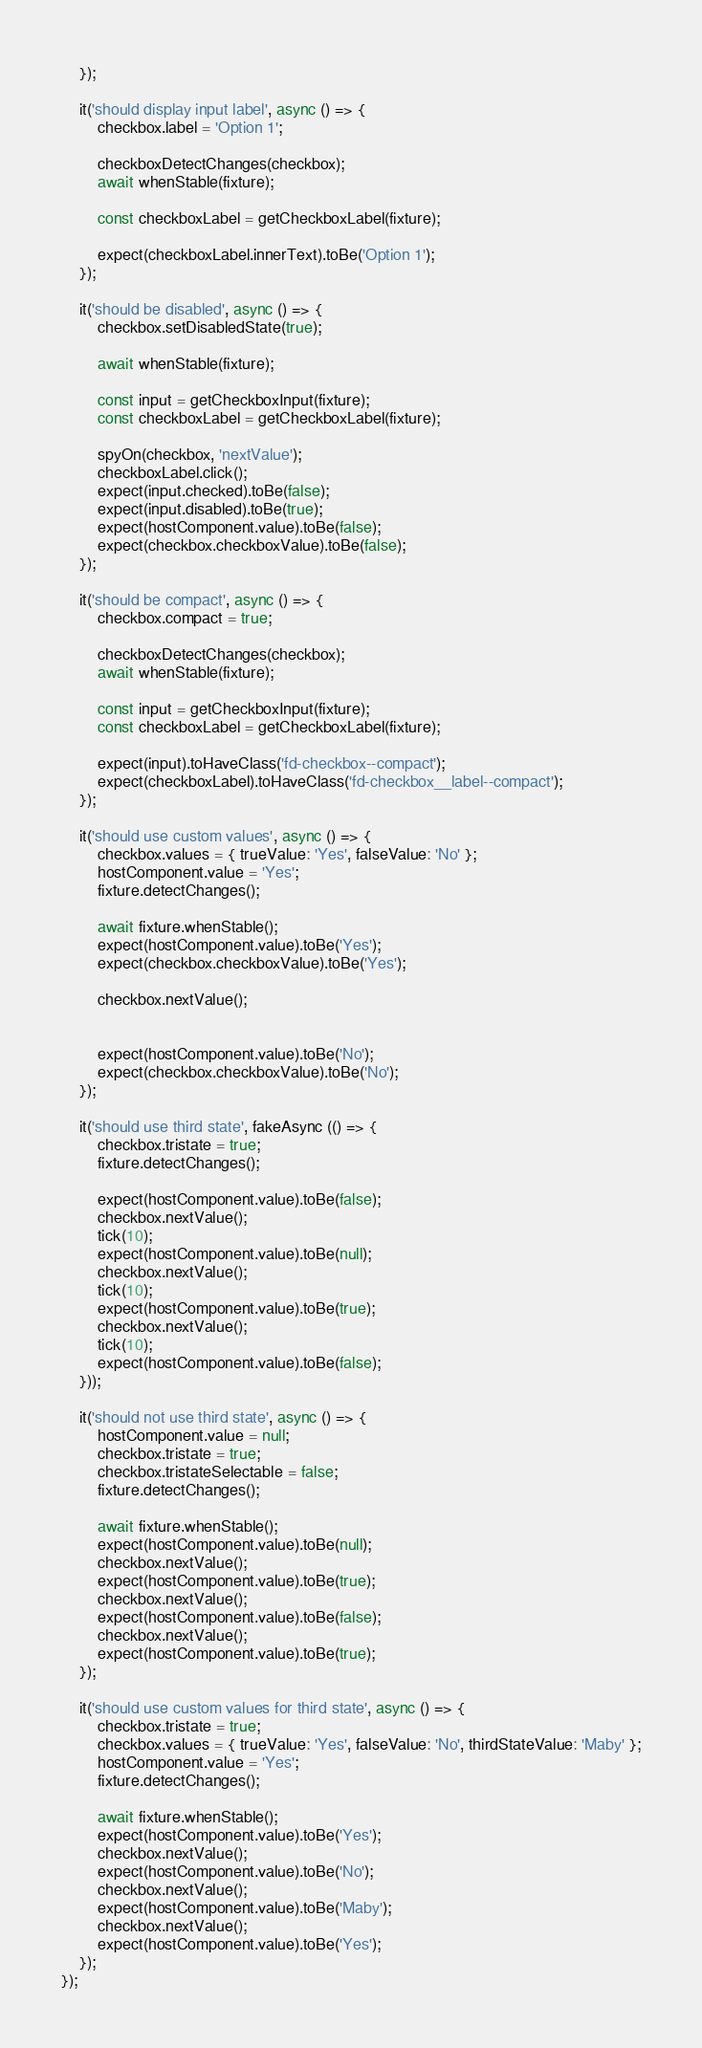Convert code to text. <code><loc_0><loc_0><loc_500><loc_500><_TypeScript_>    });

    it('should display input label', async () => {
        checkbox.label = 'Option 1';

        checkboxDetectChanges(checkbox);
        await whenStable(fixture);

        const checkboxLabel = getCheckboxLabel(fixture);

        expect(checkboxLabel.innerText).toBe('Option 1');
    });

    it('should be disabled', async () => {
        checkbox.setDisabledState(true);

        await whenStable(fixture);

        const input = getCheckboxInput(fixture);
        const checkboxLabel = getCheckboxLabel(fixture);

        spyOn(checkbox, 'nextValue');
        checkboxLabel.click();
        expect(input.checked).toBe(false);
        expect(input.disabled).toBe(true);
        expect(hostComponent.value).toBe(false);
        expect(checkbox.checkboxValue).toBe(false);
    });

    it('should be compact', async () => {
        checkbox.compact = true;

        checkboxDetectChanges(checkbox);
        await whenStable(fixture);

        const input = getCheckboxInput(fixture);
        const checkboxLabel = getCheckboxLabel(fixture);

        expect(input).toHaveClass('fd-checkbox--compact');
        expect(checkboxLabel).toHaveClass('fd-checkbox__label--compact');
    });

    it('should use custom values', async () => {
        checkbox.values = { trueValue: 'Yes', falseValue: 'No' };
        hostComponent.value = 'Yes';
        fixture.detectChanges();

        await fixture.whenStable();
        expect(hostComponent.value).toBe('Yes');
        expect(checkbox.checkboxValue).toBe('Yes');

        checkbox.nextValue();


        expect(hostComponent.value).toBe('No');
        expect(checkbox.checkboxValue).toBe('No');
    });

    it('should use third state', fakeAsync (() => {
        checkbox.tristate = true;
        fixture.detectChanges();

        expect(hostComponent.value).toBe(false);
        checkbox.nextValue();
        tick(10);
        expect(hostComponent.value).toBe(null);
        checkbox.nextValue();
        tick(10);
        expect(hostComponent.value).toBe(true);
        checkbox.nextValue();
        tick(10);
        expect(hostComponent.value).toBe(false);
    }));

    it('should not use third state', async () => {
        hostComponent.value = null;
        checkbox.tristate = true;
        checkbox.tristateSelectable = false;
        fixture.detectChanges();

        await fixture.whenStable();
        expect(hostComponent.value).toBe(null);
        checkbox.nextValue();
        expect(hostComponent.value).toBe(true);
        checkbox.nextValue();
        expect(hostComponent.value).toBe(false);
        checkbox.nextValue();
        expect(hostComponent.value).toBe(true);
    });

    it('should use custom values for third state', async () => {
        checkbox.tristate = true;
        checkbox.values = { trueValue: 'Yes', falseValue: 'No', thirdStateValue: 'Maby' };
        hostComponent.value = 'Yes';
        fixture.detectChanges();

        await fixture.whenStable();
        expect(hostComponent.value).toBe('Yes');
        checkbox.nextValue();
        expect(hostComponent.value).toBe('No');
        checkbox.nextValue();
        expect(hostComponent.value).toBe('Maby');
        checkbox.nextValue();
        expect(hostComponent.value).toBe('Yes');
    });
});
</code> 